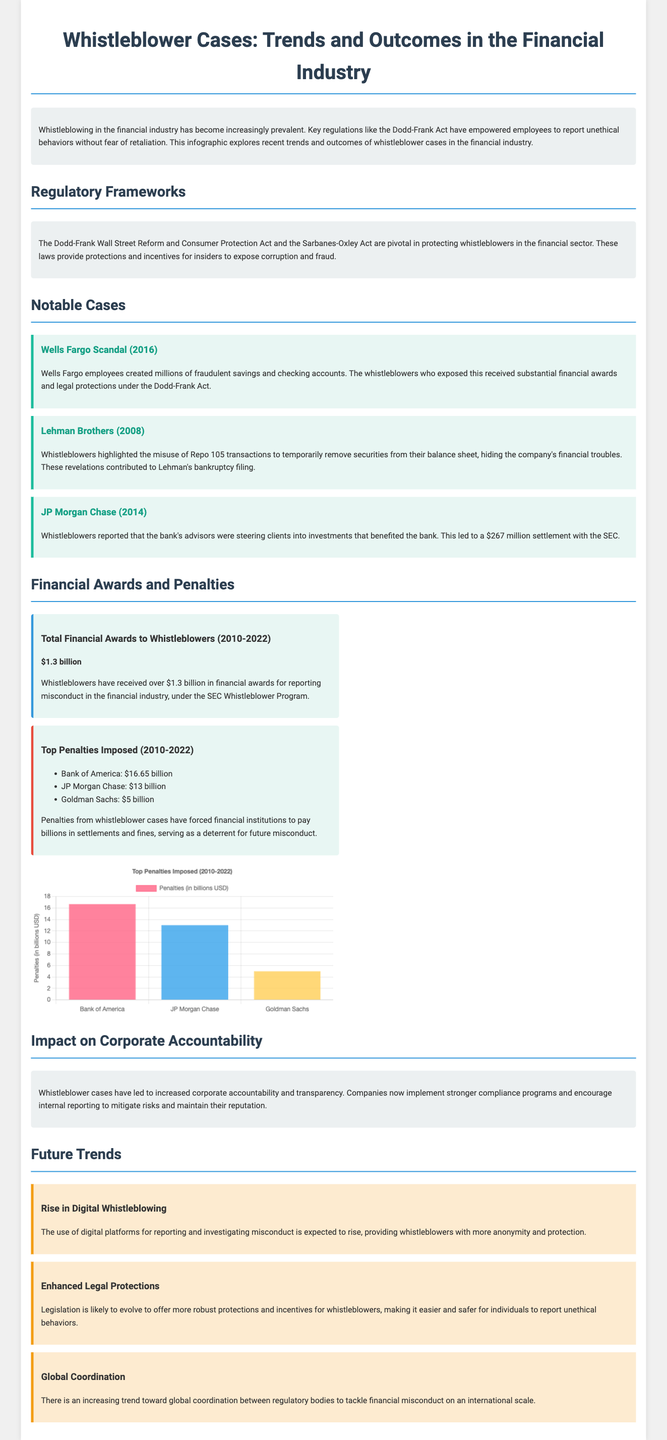What is the total financial awards to whistleblowers from 2010 to 2022? The total financial awards are explicitly stated in the document as over $1.3 billion for that period.
Answer: $1.3 billion Which act is mentioned as pivotal in protecting whistleblowers? The document highlights the Dodd-Frank Wall Street Reform and Consumer Protection Act in this context.
Answer: Dodd-Frank Act What year did the Wells Fargo scandal occur? The document clearly states that the scandal involving Wells Fargo occurred in 2016.
Answer: 2016 What was the penalty imposed on Bank of America? The document lists the penalty amounts, and specifically identifies Bank of America's penalty as $16.65 billion.
Answer: $16.65 billion What trend is expected to rise regarding whistleblowing? The document mentions the anticipated rise in the use of digital platforms for reporting misconduct.
Answer: Rise in Digital Whistleblowing Total amount in penalties imposed on JP Morgan Chase? The document explicitly indicates the penalty imposed on JP Morgan Chase as $13 billion.
Answer: $13 billion What significant outcome have whistleblower cases led to in corporations? Increased corporate accountability is emphasized as a significant outcome of whistleblower cases in the document.
Answer: Increased corporate accountability What financial settlement was reported for JP Morgan Chase? The document states a settlement amount of $267 million for JP Morgan Chase regarding whistleblower reports.
Answer: $267 million What is noted as a legal evolution for whistleblowers? The document mentions enhanced legal protections as a likely evolution for whistleblowers in the future.
Answer: Enhanced Legal Protections 